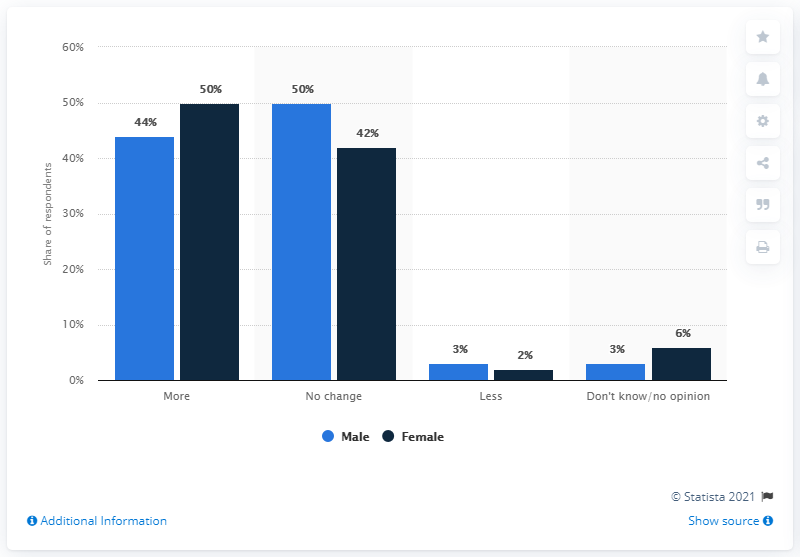Indicate a few pertinent items in this graphic. In terms of opinion, the one with the least difference between males and females is: "Less" is the opinion with the least difference between males and females. The highest value indicated by the navy blue bar is 50. 